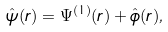Convert formula to latex. <formula><loc_0><loc_0><loc_500><loc_500>\hat { \psi } ( r ) = \Psi ^ { ( 1 ) } ( r ) + \hat { \phi } ( r ) ,</formula> 